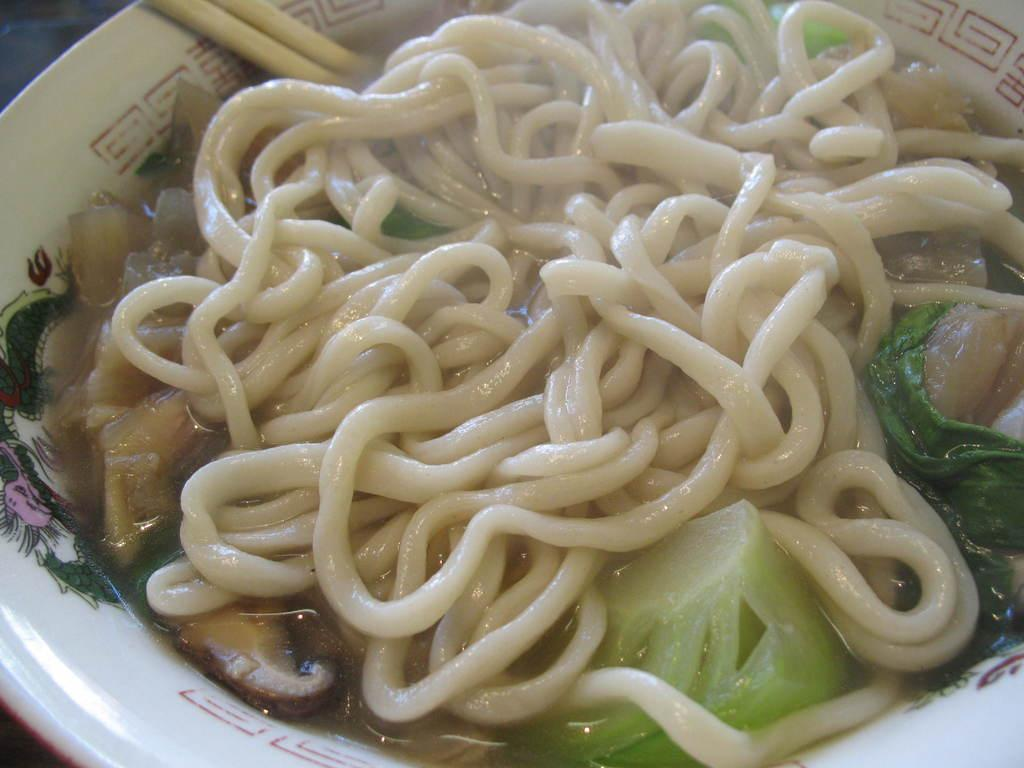What is in the cup that is visible in the image? There is a cup of noodles in the image. Besides noodles, what other items can be seen in the image? There are veggies and chopsticks visible in the image. What type of bead is used to decorate the monkey's plot in the image? There is no bead, monkey, or plot present in the image. 